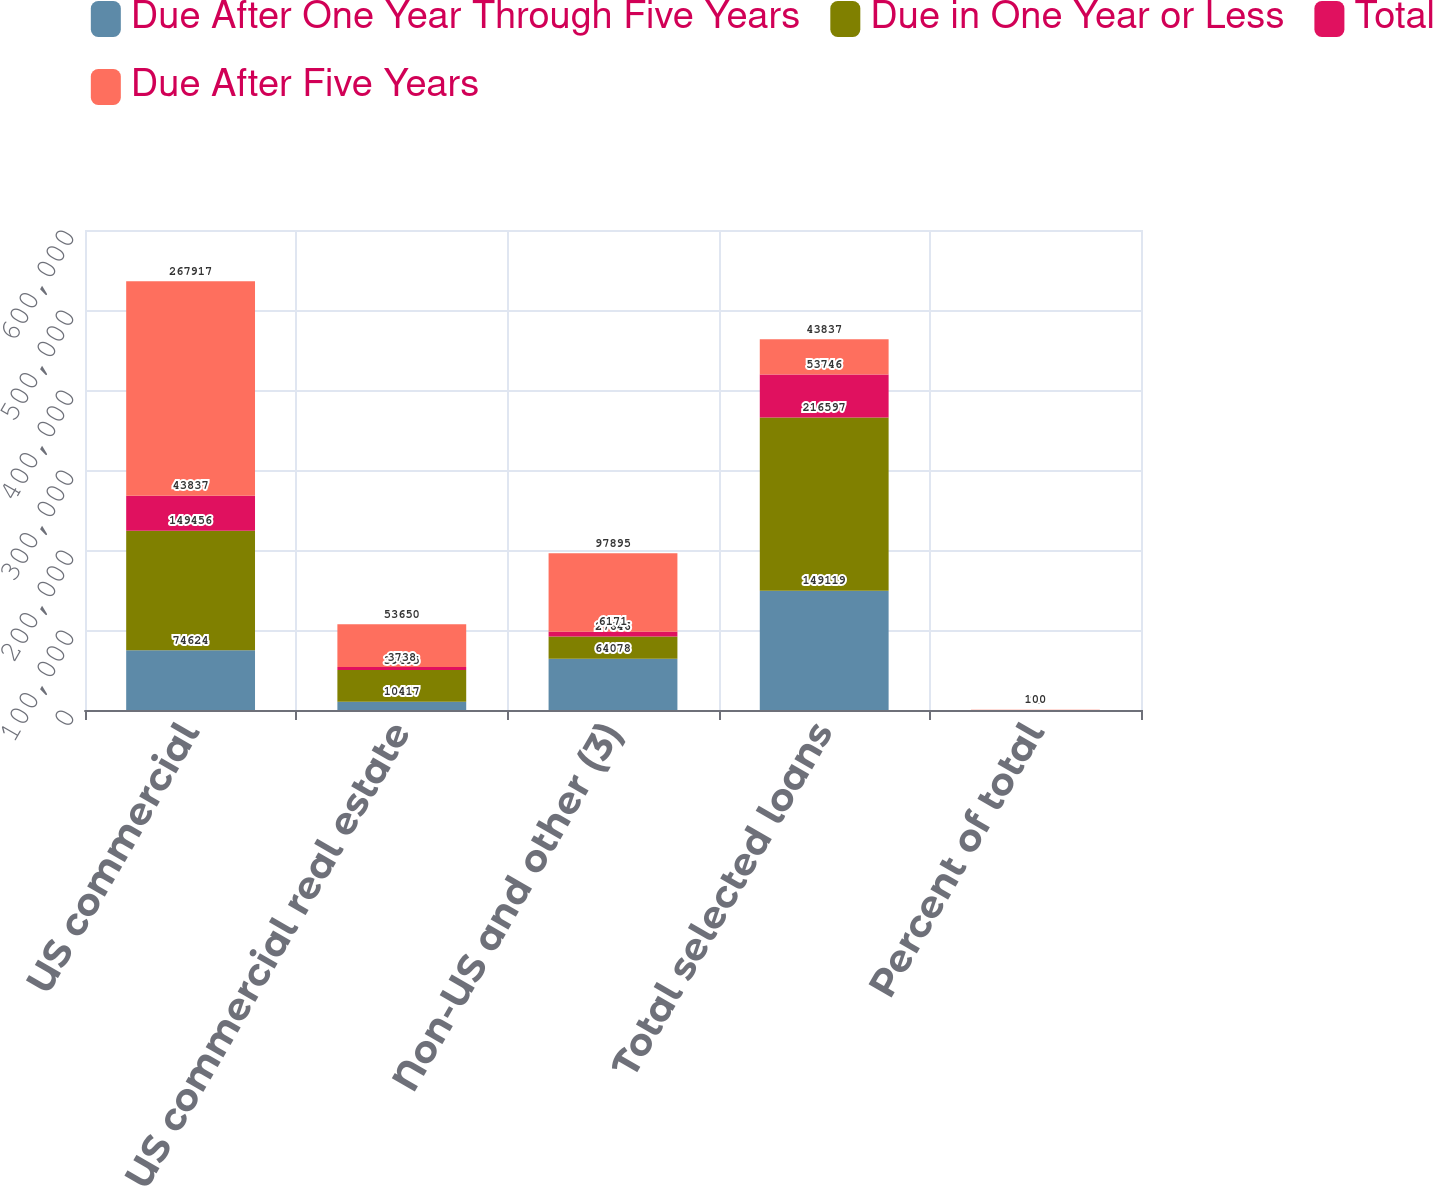Convert chart to OTSL. <chart><loc_0><loc_0><loc_500><loc_500><stacked_bar_chart><ecel><fcel>US commercial<fcel>US commercial real estate<fcel>Non-US and other (3)<fcel>Total selected loans<fcel>Percent of total<nl><fcel>Due After One Year Through Five Years<fcel>74624<fcel>10417<fcel>64078<fcel>149119<fcel>36<nl><fcel>Due in One Year or Less<fcel>149456<fcel>39495<fcel>27646<fcel>216597<fcel>51<nl><fcel>Total<fcel>43837<fcel>3738<fcel>6171<fcel>53746<fcel>13<nl><fcel>Due After Five Years<fcel>267917<fcel>53650<fcel>97895<fcel>43837<fcel>100<nl></chart> 